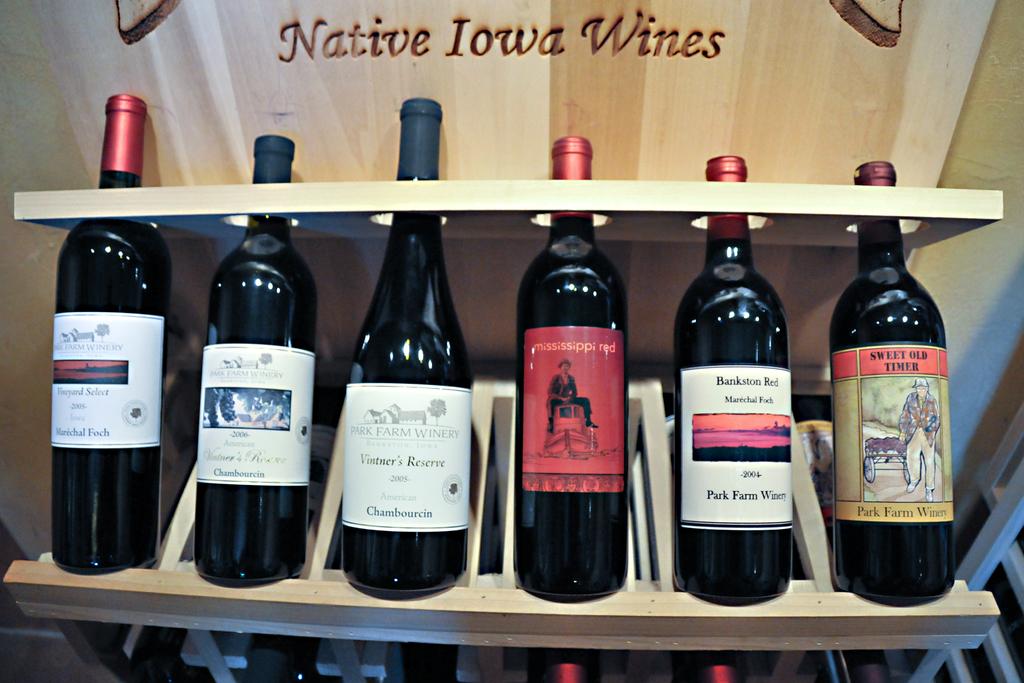What kind of wines are these?
Your response must be concise. Native iowa wines. From which us state those wines come from ?
Make the answer very short. Iowa. 